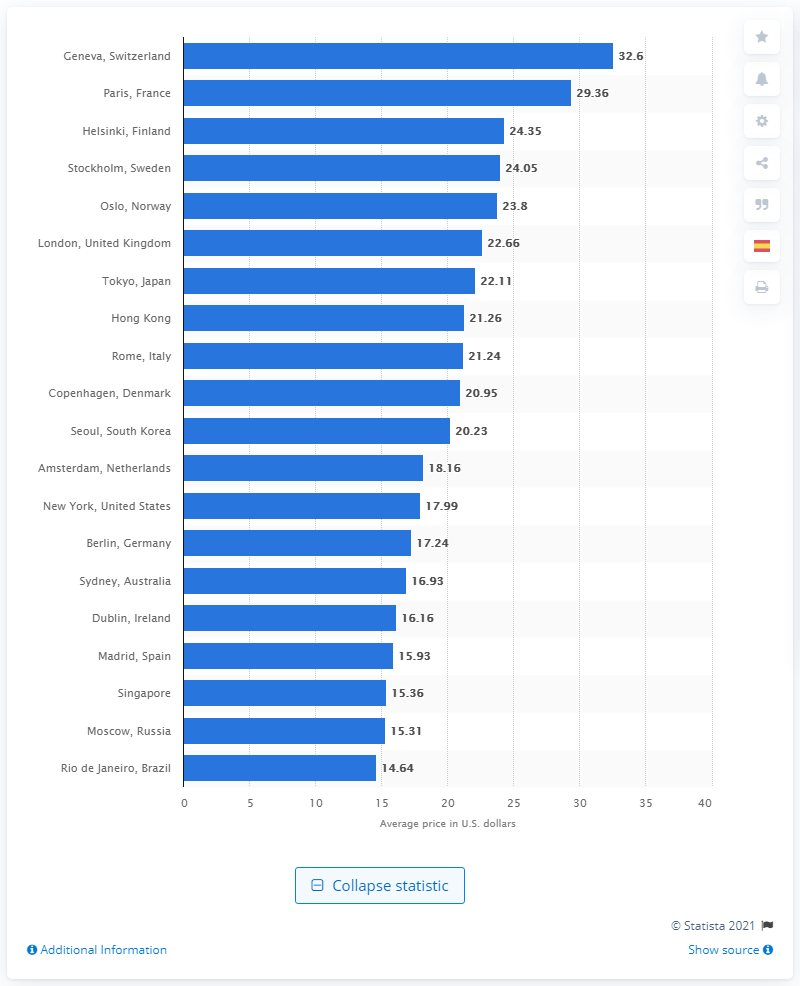Point out several critical features in this image. In 2014, the city of Geneva, Switzerland was reportedly the most expensive place in the world to purchase a Club Sandwich. The average price of a Club Sandwich in 2014 was 32.6 dollars. 